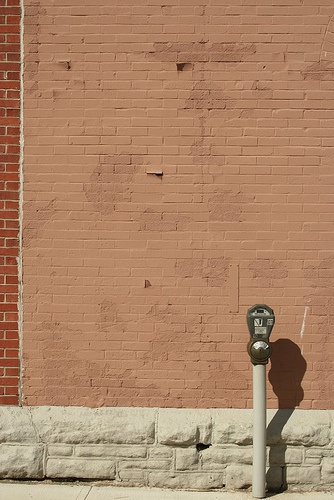Describe the objects in this image and their specific colors. I can see a parking meter in maroon, black, and gray tones in this image. 